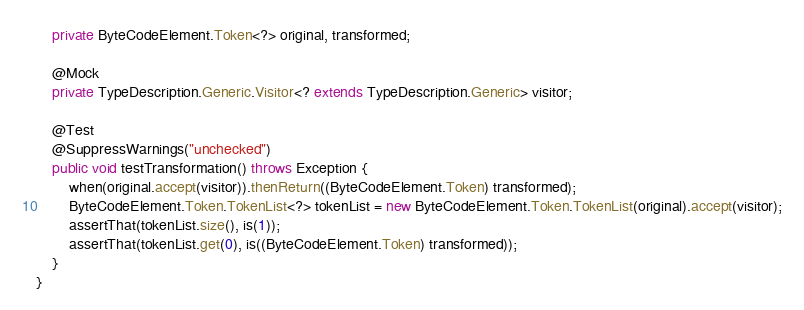<code> <loc_0><loc_0><loc_500><loc_500><_Java_>    private ByteCodeElement.Token<?> original, transformed;

    @Mock
    private TypeDescription.Generic.Visitor<? extends TypeDescription.Generic> visitor;

    @Test
    @SuppressWarnings("unchecked")
    public void testTransformation() throws Exception {
        when(original.accept(visitor)).thenReturn((ByteCodeElement.Token) transformed);
        ByteCodeElement.Token.TokenList<?> tokenList = new ByteCodeElement.Token.TokenList(original).accept(visitor);
        assertThat(tokenList.size(), is(1));
        assertThat(tokenList.get(0), is((ByteCodeElement.Token) transformed));
    }
}
</code> 